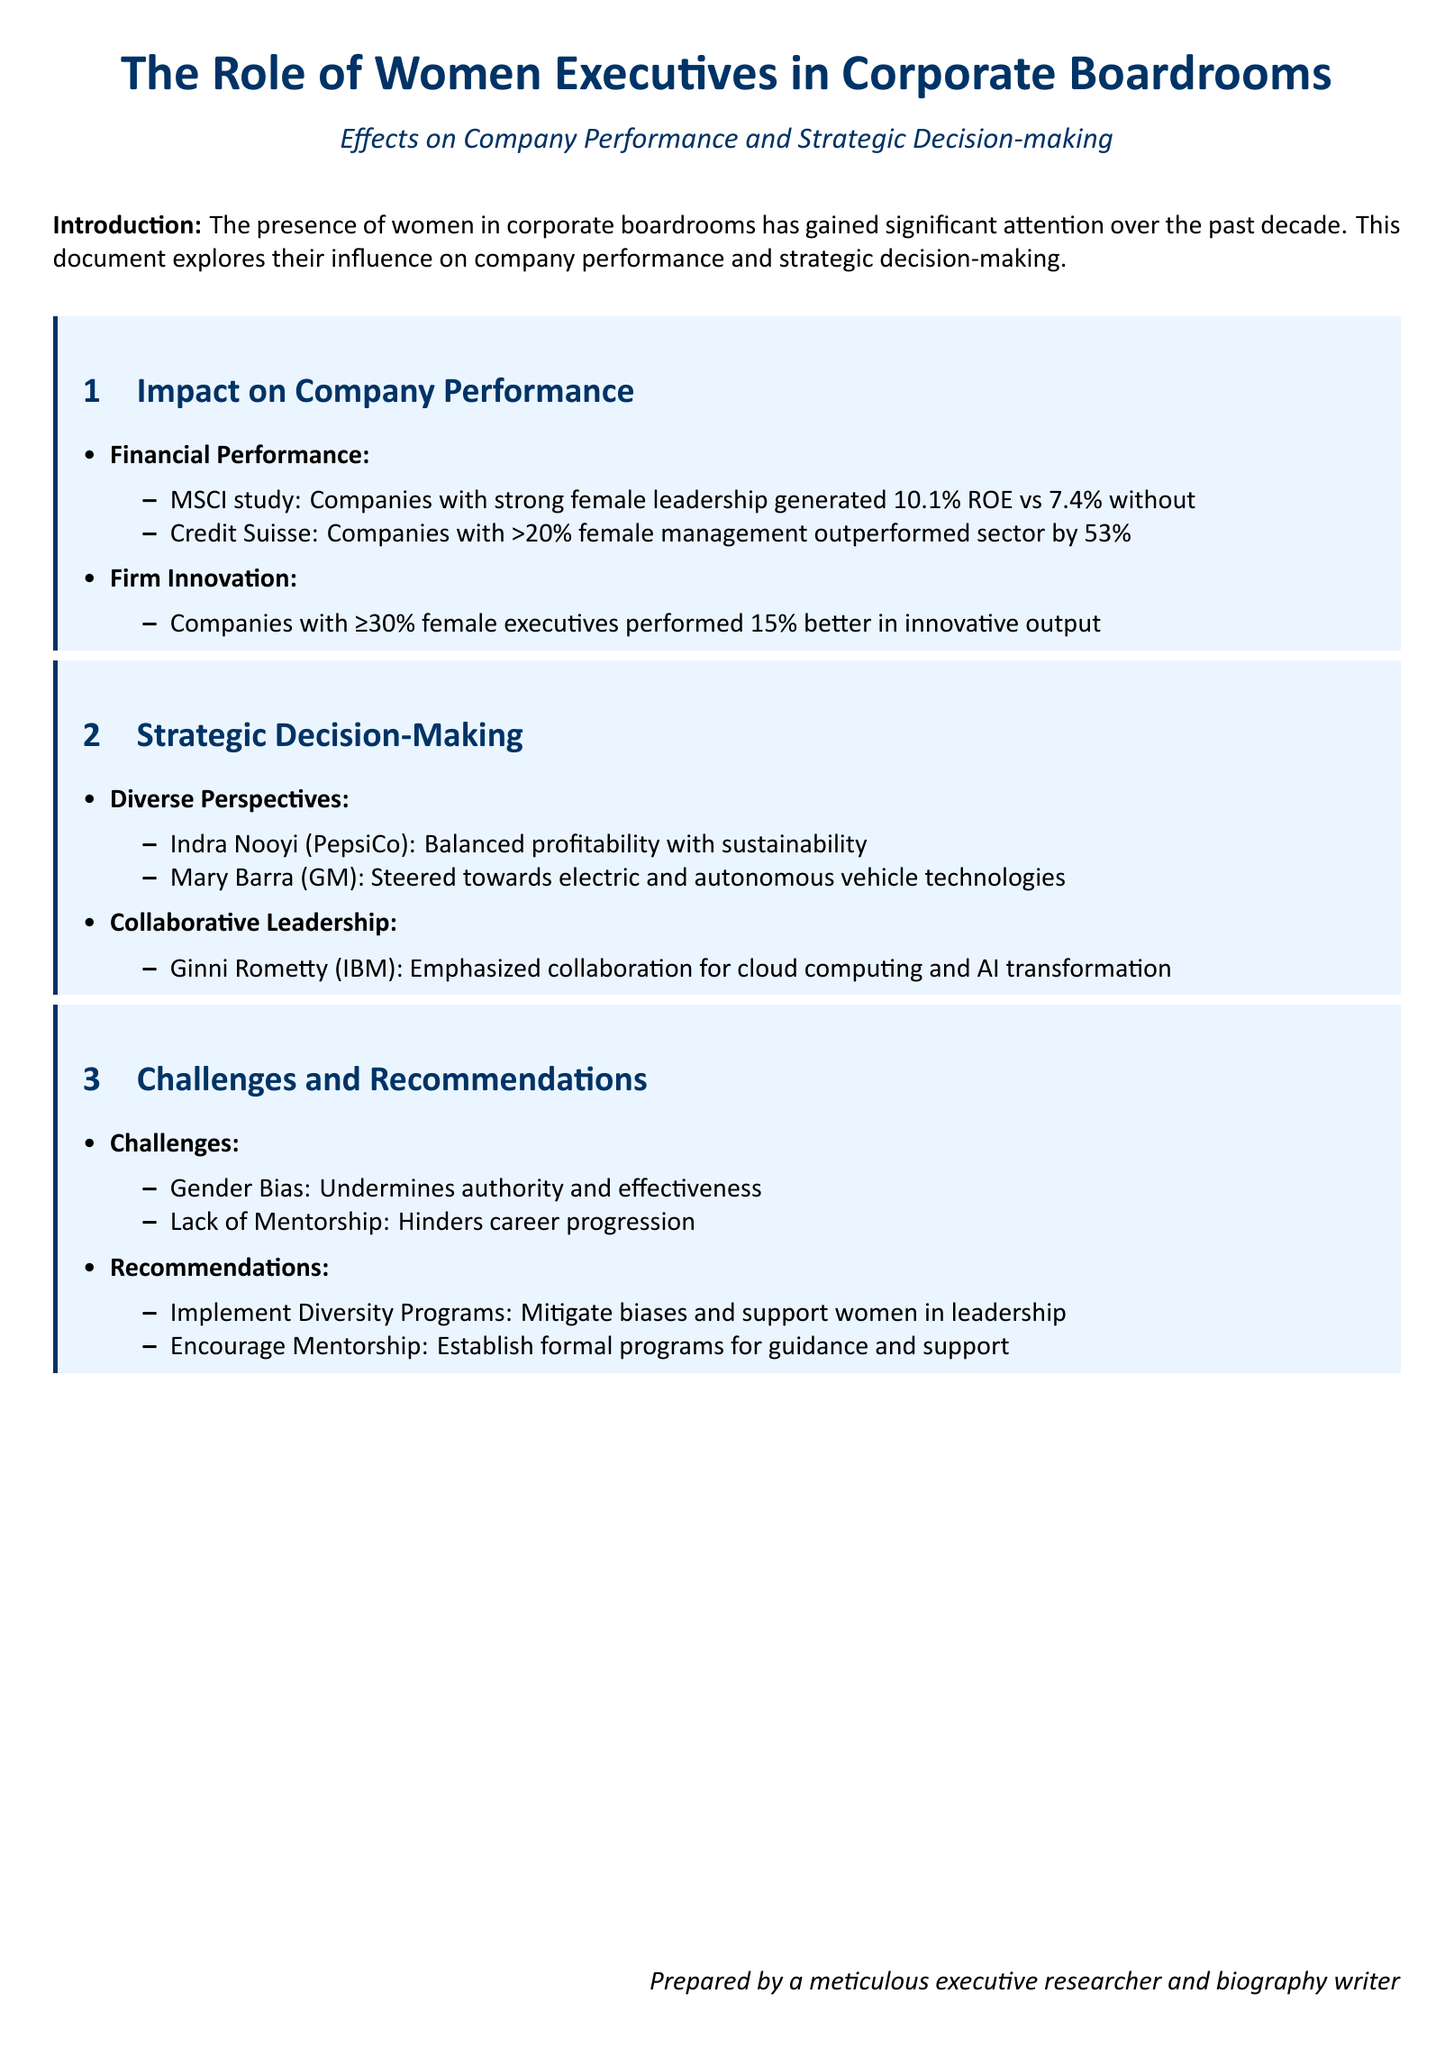What was the ROE for companies with strong female leadership? The document cites that companies with strong female leadership generated a 10.1% ROE.
Answer: 10.1% What is the percentage performance increase for companies with more than 20% female management? The document states that these companies outperformed their sector by 53%.
Answer: 53% How much better did companies with at least 30% female executives perform in innovative output? The document notes they performed 15% better in innovative output.
Answer: 15% Who is the executive from PepsiCo mentioned in the document? The text references Indra Nooyi as the executive from PepsiCo.
Answer: Indra Nooyi What did Ginni Rometty emphasize as important for IBM’s transformation? The document indicates she emphasized collaboration for cloud computing and AI transformation.
Answer: Collaboration What are two challenges mentioned that women executives face? The document lists gender bias and lack of mentorship as challenges.
Answer: Gender bias, lack of mentorship What is one recommendation to mitigate biases in corporate leadership? The document suggests implementing diversity programs as a recommendation.
Answer: Implement diversity programs What does Mary Barra's strategic focus involve? The document states she steered towards electric and autonomous vehicle technologies.
Answer: Electric and autonomous vehicle technologies 